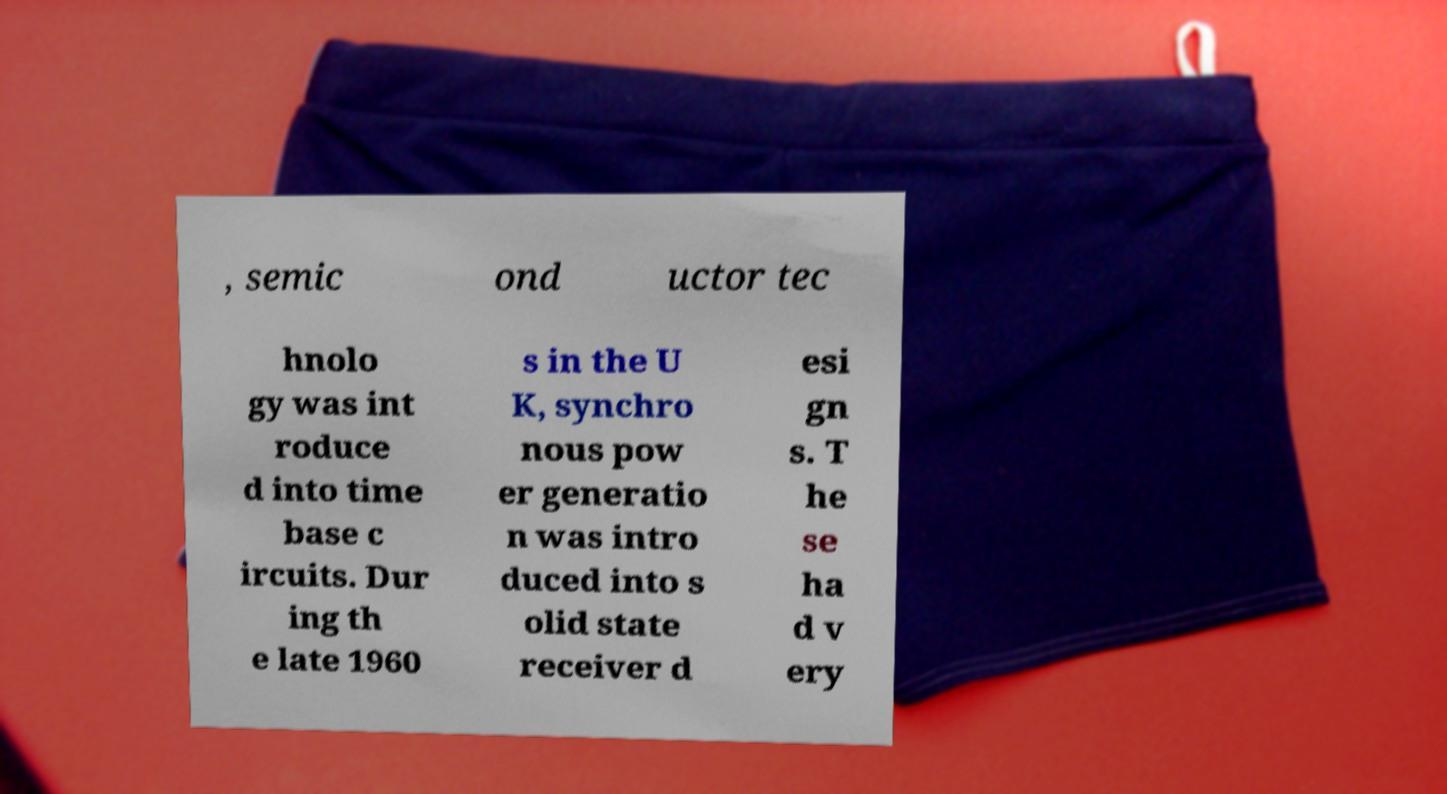There's text embedded in this image that I need extracted. Can you transcribe it verbatim? , semic ond uctor tec hnolo gy was int roduce d into time base c ircuits. Dur ing th e late 1960 s in the U K, synchro nous pow er generatio n was intro duced into s olid state receiver d esi gn s. T he se ha d v ery 